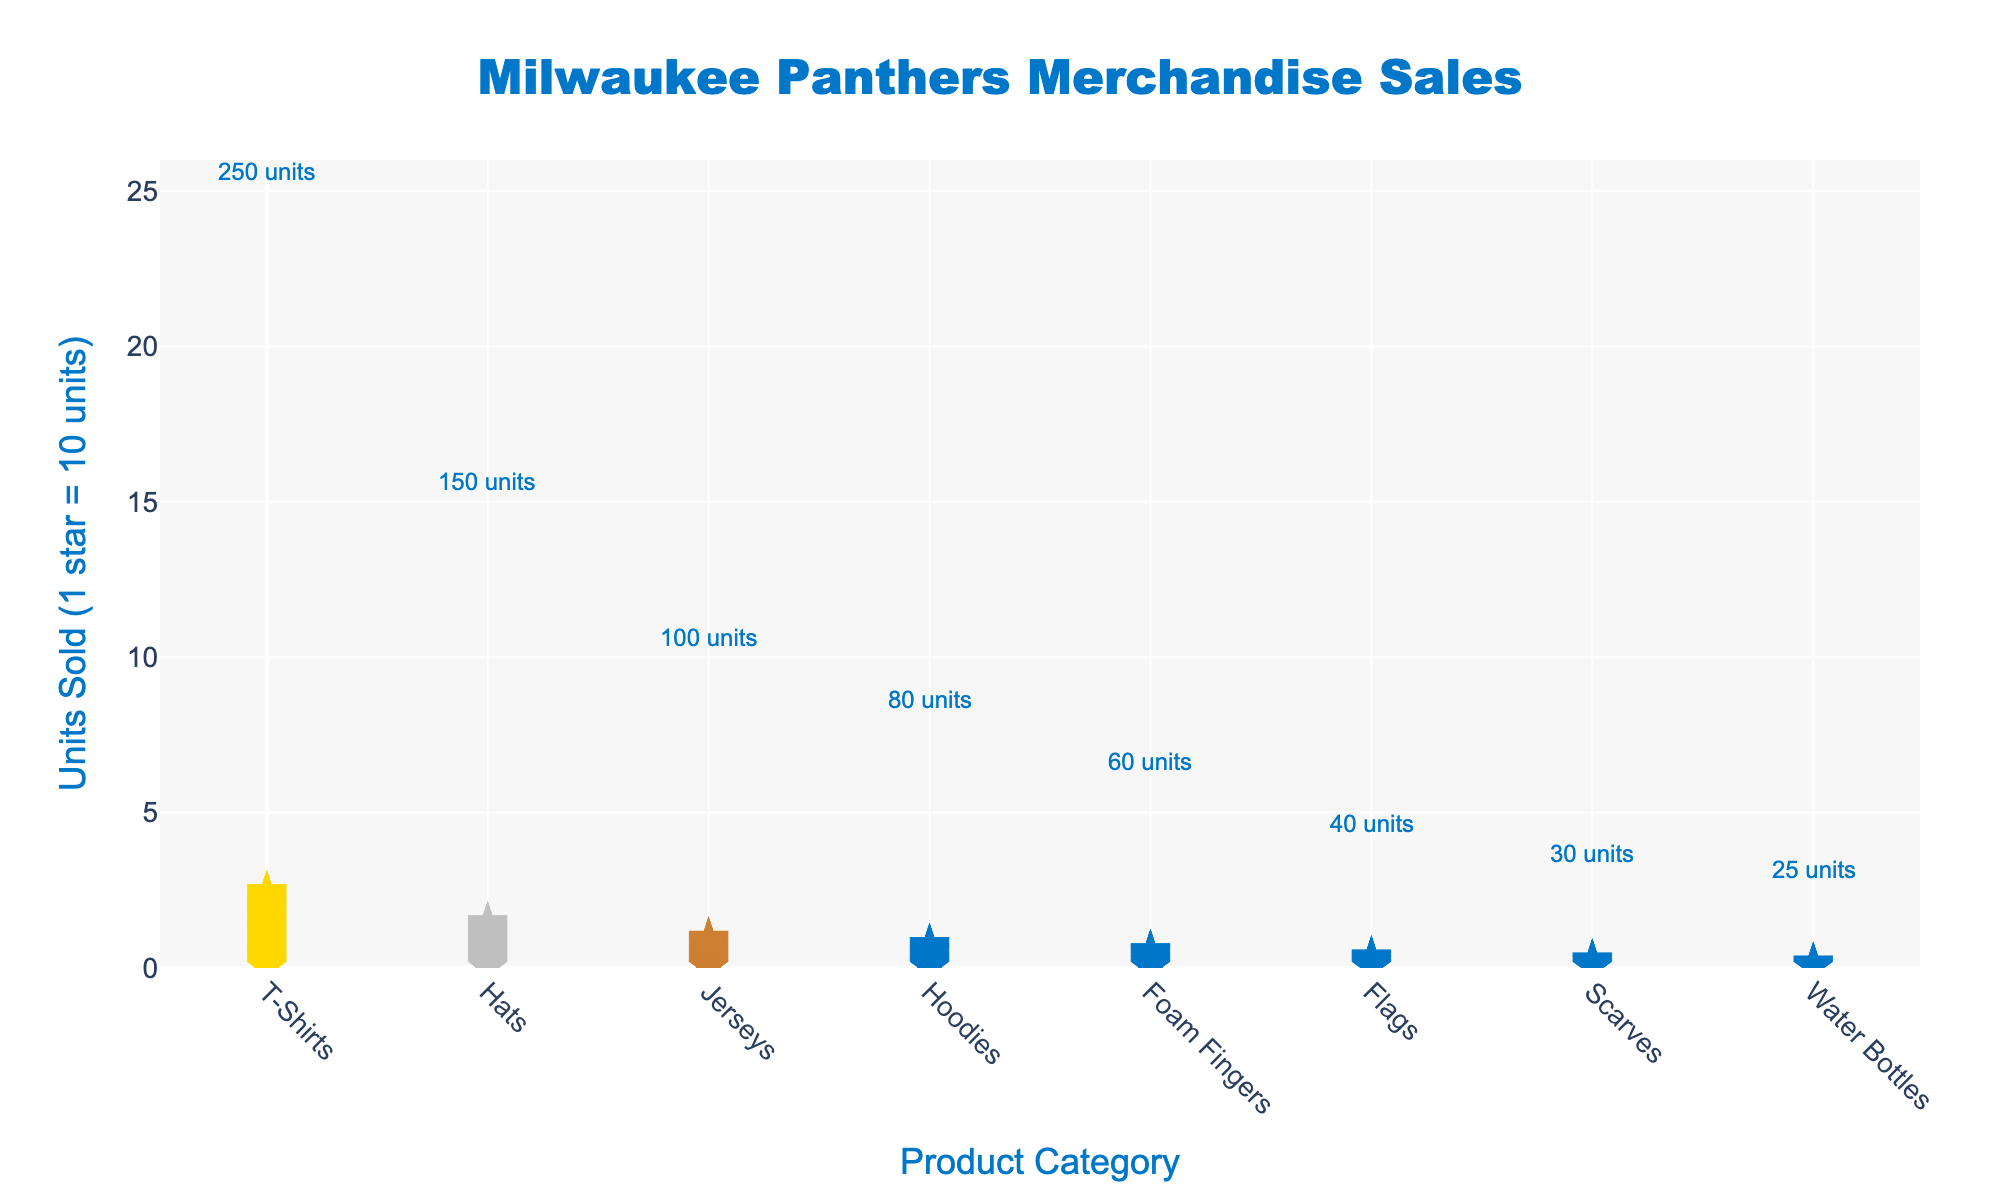How many product categories are displayed in the plot? Count the number of unique categories listed on the x-axis. The x-axis shows the categories T-Shirts, Hats, Jerseys, Hoodies, Foam Fingers, Flags, Scarves, and Water Bottles. There are 8 categories in total.
Answer: 8 Which product category has the highest number of units sold? Observe the tallest column of stars representing the units sold. The category with the highest number of units sold is T-Shirts, which has 250 units sold.
Answer: T-Shirts By how many units does the category with the least sales differ from Hoodies? Identify the units sold for Hoodies and the product category with the least sales (Water Bottles). Hoodies have 80 units sold, and Water Bottles have 25 units sold. The difference is 80 - 25 = 55 units.
Answer: 55 units How many stars represent the number of units sold for Jerseys? Each star represents 10 units. Count the stars for Jerseys to get the total units sold. There are 10 stars for Jerseys, indicating 100 units sold.
Answer: 10 What is the total number of units sold for the categories Hats, Jerseys, and Hoodies combined? Add the units sold for Hats, Jerseys, and Hoodies. Hats have 150 units, Jerseys have 100 units, and Hoodies have 80 units. The total is 150 + 100 + 80 = 330 units.
Answer: 330 units Which categories have equal units sold? Verify the unit counts for categories and check for any equal values among them. There are no categories with equal units sold in the plot.
Answer: None Which product category ranks third in terms of units sold? Identify the third tallest column of stars. The third highest number of units sold is for Jerseys, with 100 units sold.
Answer: Jerseys How many stars would be present for Flags if each star represented 5 units instead of 10? Flags have 40 units sold. If each star represents 5 units, the number of stars would be 40 / 5 = 8.
Answer: 8 What is the median number of units sold among all product categories? List the units sold in ascending order: 25, 30, 40, 60, 80, 100, 150, 250. The median is the average of the middle two values, (60 + 80)/2 = 70.
Answer: 70 